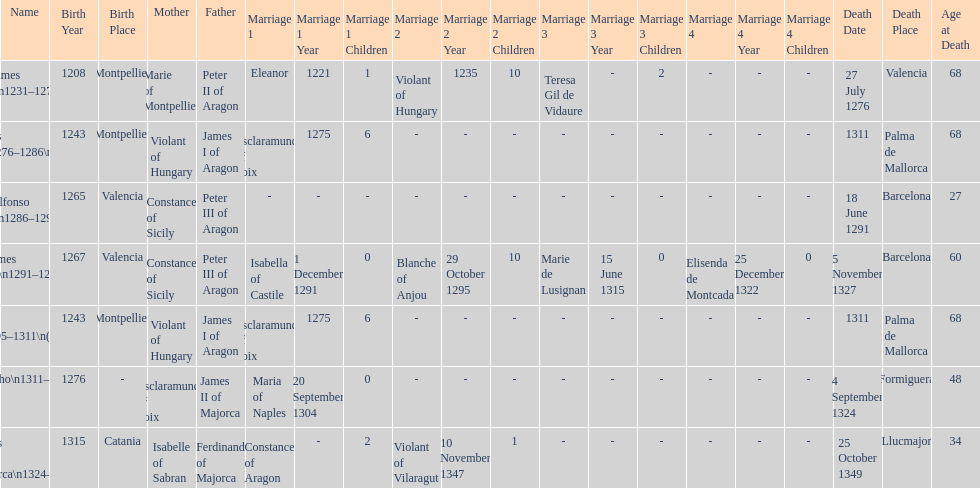What name is above james iii and below james ii? Alfonso I. 